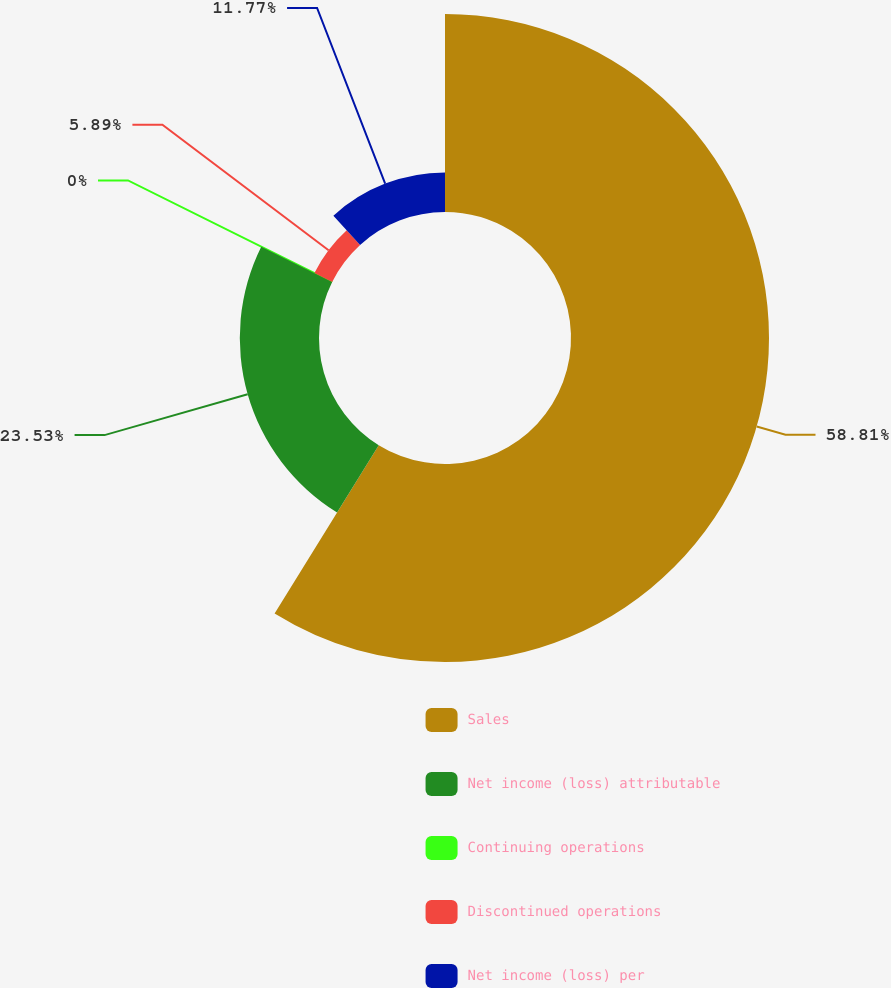<chart> <loc_0><loc_0><loc_500><loc_500><pie_chart><fcel>Sales<fcel>Net income (loss) attributable<fcel>Continuing operations<fcel>Discontinued operations<fcel>Net income (loss) per<nl><fcel>58.82%<fcel>23.53%<fcel>0.0%<fcel>5.89%<fcel>11.77%<nl></chart> 